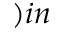Convert formula to latex. <formula><loc_0><loc_0><loc_500><loc_500>) i n</formula> 